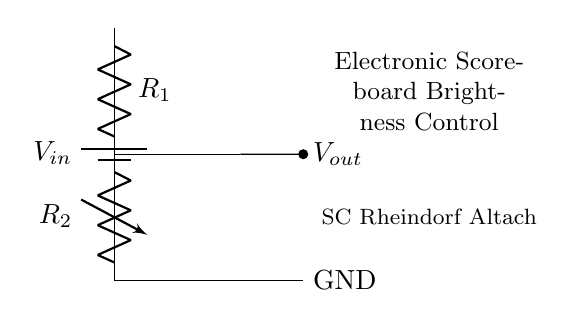What is the name of the variable resistor in this circuit? The circuit diagram labels the variable resistor as R2. This is indicated by the notation used in the drawing, where it specifically identifies the component as a variable resistor.
Answer: R2 What component controls the output voltage? The output voltage, Vout, is controlled by the variable resistor, R2, which adjusts the resistance in the circuit. This change in resistance affects how much voltage is dropped across R2, allowing for control over Vout.
Answer: R2 What is the purpose of the circuit? The circuit's purpose is specifically mentioned in the node labeling within the diagram, indicating that it is for controlling the brightness of an electronic scoreboard. This suggests that adjusting the circuit will change the brightness accordingly.
Answer: Electronic Scoreboard Brightness Control What is the output voltage connected to? The output voltage, Vout, is directly connected to the point marked in the circuit before the ground, indicating its relationship with the rest of the schmooze. Since there's no other component between Vout and R2, it concludes that Vout is used for a final control point before further connections can be made.
Answer: Vout How many resistors are used in this circuit? The diagram shows there are two resistors: R1 which is fixed, and R2 which is variable. Each is clearly labeled in the schematic design.
Answer: Two resistors If R2 is adjusted to its maximum level, what happens to Vout? When R2 is adjusted to its maximum level, it increases resistance, which leads to a higher voltage drop across R2. Consequently, the voltage Vout would decrease, as it is determined by the proportion of R2's value compared to the circuit's total resistance. This relationship illustrates how changing one resistor influences the whole circuit's output.
Answer: Vout decreases What do you expect Vout to be when R2 is at minimum resistance? When R2 is at minimum resistance, it means less voltage is dropped across it, allowing more of the input voltage Vin to appear across Vout. Since no other components are affecting this relationship, we conclude that Vout will approach Vin when R2's resistance is minimized.
Answer: Approaches Vin 